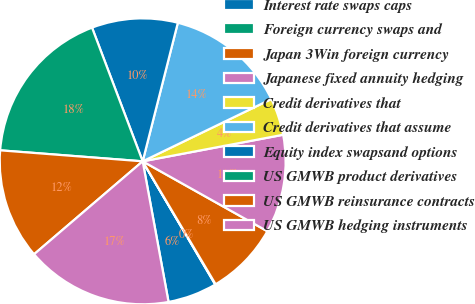Convert chart to OTSL. <chart><loc_0><loc_0><loc_500><loc_500><pie_chart><fcel>Interest rate swaps caps<fcel>Foreign currency swaps and<fcel>Japan 3Win foreign currency<fcel>Japanese fixed annuity hedging<fcel>Credit derivatives that<fcel>Credit derivatives that assume<fcel>Equity index swapsand options<fcel>US GMWB product derivatives<fcel>US GMWB reinsurance contracts<fcel>US GMWB hedging instruments<nl><fcel>5.58%<fcel>0.05%<fcel>8.34%<fcel>11.11%<fcel>4.2%<fcel>13.87%<fcel>9.72%<fcel>18.01%<fcel>12.49%<fcel>16.63%<nl></chart> 